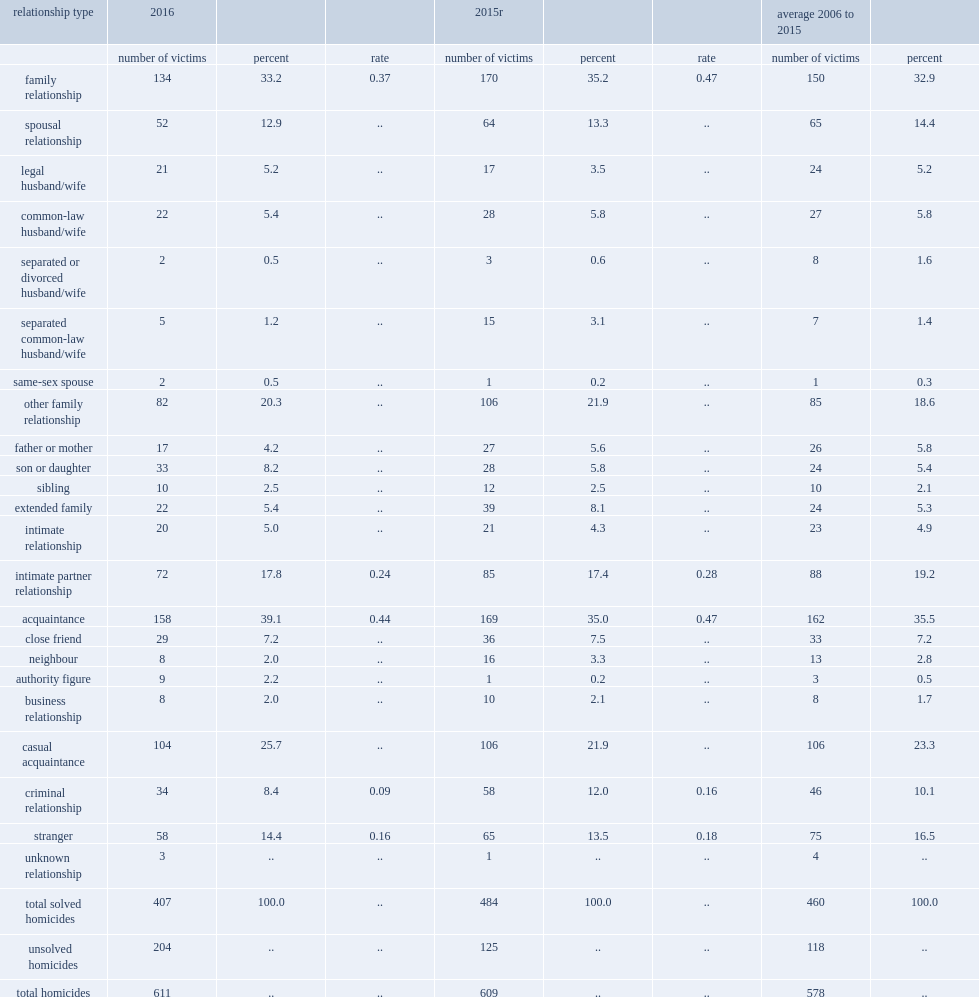What were the numbers of victims killed by a stranger in 2016 and 2015 respectively? 58.0 65.0. What were the rates of homicides committed by a person with whom the victim had a criminal relationship in 2015 and 2016 respectively? 12.0 8.4. What were the rates of homicides committed by other family relationship in 2016 and 2015 respectively? 20.3 21.9. What was the number of intimate partner homicides reported in canada in 2016? 72.0. What were the rates of intimate partner homicides reported in 2016 and 2015 respectively? 0.24 0.28. What were the percentages of the proportion of intimate partner related homicides in 2016 and the average of the previous 10 years respectively? 17.8 19.2. 